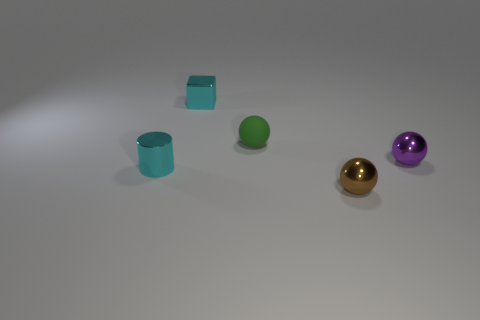There is a small metallic thing that is the same color as the tiny metallic block; what shape is it?
Provide a succinct answer. Cylinder. Is the shape of the purple object the same as the small brown shiny thing?
Offer a very short reply. Yes. There is a object that is both behind the small brown metal ball and to the right of the green matte ball; what is its material?
Provide a short and direct response. Metal. There is another metal object that is the same shape as the small purple metal thing; what color is it?
Provide a succinct answer. Brown. Is there any other thing of the same color as the tiny cylinder?
Your answer should be very brief. Yes. Do the shiny sphere behind the tiny cylinder and the sphere that is to the left of the brown object have the same size?
Ensure brevity in your answer.  Yes. Are there the same number of brown spheres in front of the brown thing and cyan things behind the block?
Give a very brief answer. Yes. There is a brown thing; is it the same size as the cyan metallic thing behind the rubber thing?
Ensure brevity in your answer.  Yes. Are there any cyan shiny things that are behind the tiny cyan cylinder that is in front of the small purple object?
Keep it short and to the point. Yes. Is there another brown object of the same shape as the matte thing?
Ensure brevity in your answer.  Yes. 